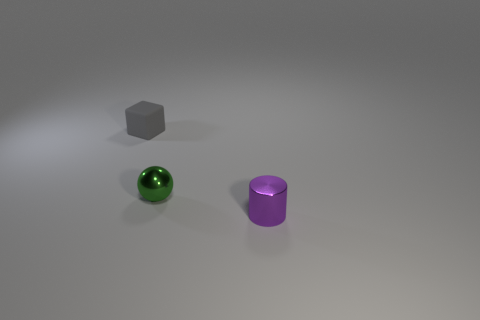Add 3 purple cylinders. How many objects exist? 6 Subtract 1 cubes. How many cubes are left? 0 Add 1 cyan matte spheres. How many cyan matte spheres exist? 1 Subtract 0 cyan cylinders. How many objects are left? 3 Subtract all cylinders. How many objects are left? 2 Subtract all cyan balls. Subtract all red cylinders. How many balls are left? 1 Subtract all gray rubber objects. Subtract all small purple things. How many objects are left? 1 Add 3 small green metal things. How many small green metal things are left? 4 